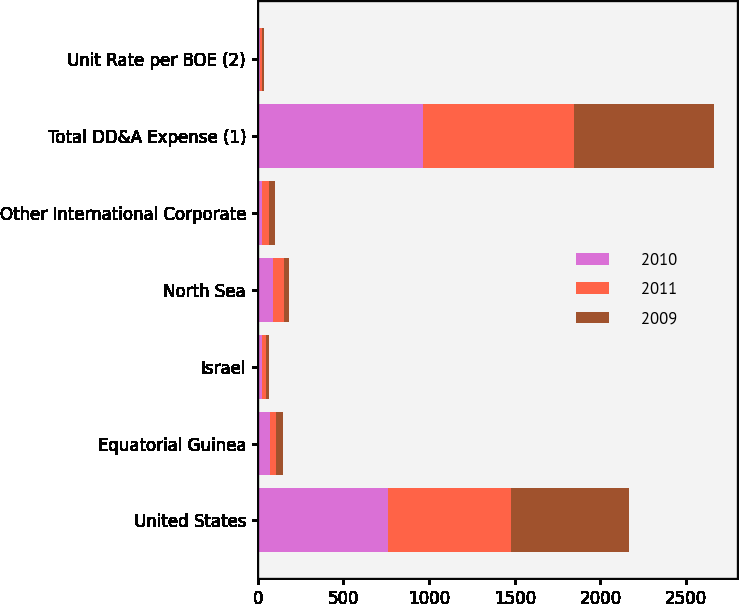Convert chart. <chart><loc_0><loc_0><loc_500><loc_500><stacked_bar_chart><ecel><fcel>United States<fcel>Equatorial Guinea<fcel>Israel<fcel>North Sea<fcel>Other International Corporate<fcel>Total DD&A Expense (1)<fcel>Unit Rate per BOE (2)<nl><fcel>2010<fcel>758<fcel>69<fcel>25<fcel>87<fcel>26<fcel>965<fcel>12.32<nl><fcel>2011<fcel>719<fcel>39<fcel>22<fcel>64<fcel>39<fcel>883<fcel>11.57<nl><fcel>2009<fcel>689<fcel>38<fcel>20<fcel>34<fcel>35<fcel>816<fcel>11.08<nl></chart> 